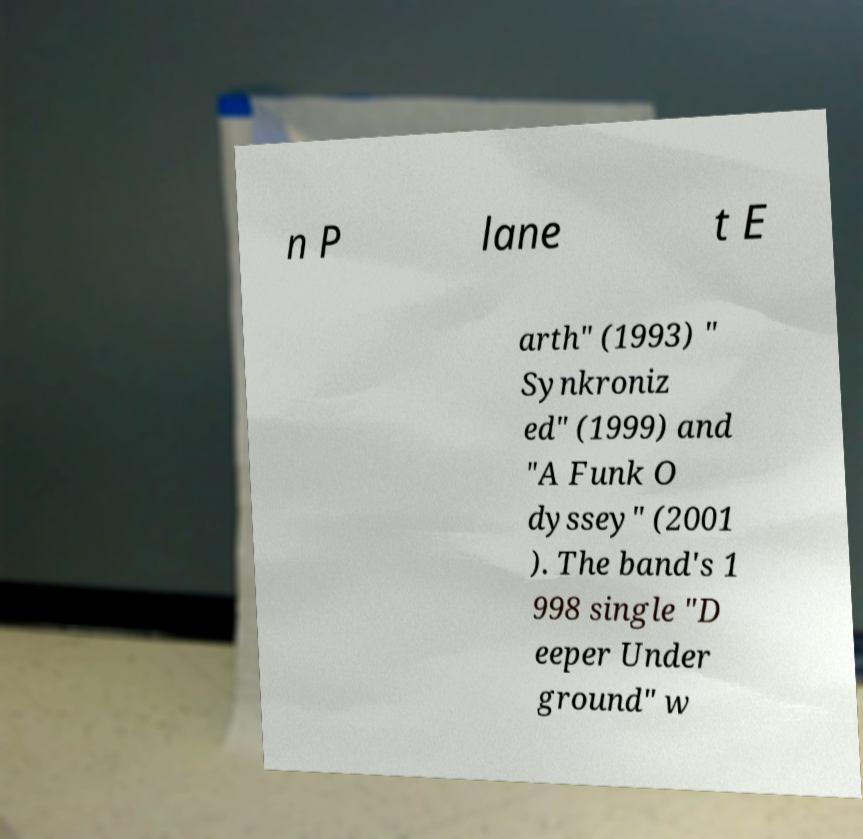There's text embedded in this image that I need extracted. Can you transcribe it verbatim? n P lane t E arth" (1993) " Synkroniz ed" (1999) and "A Funk O dyssey" (2001 ). The band's 1 998 single "D eeper Under ground" w 